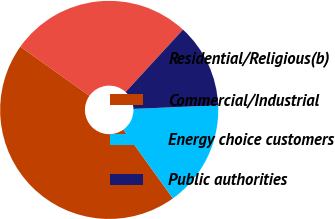Convert chart. <chart><loc_0><loc_0><loc_500><loc_500><pie_chart><fcel>Residential/Religious(b)<fcel>Commercial/Industrial<fcel>Energy choice customers<fcel>Public authorities<nl><fcel>26.99%<fcel>44.77%<fcel>15.73%<fcel>12.51%<nl></chart> 